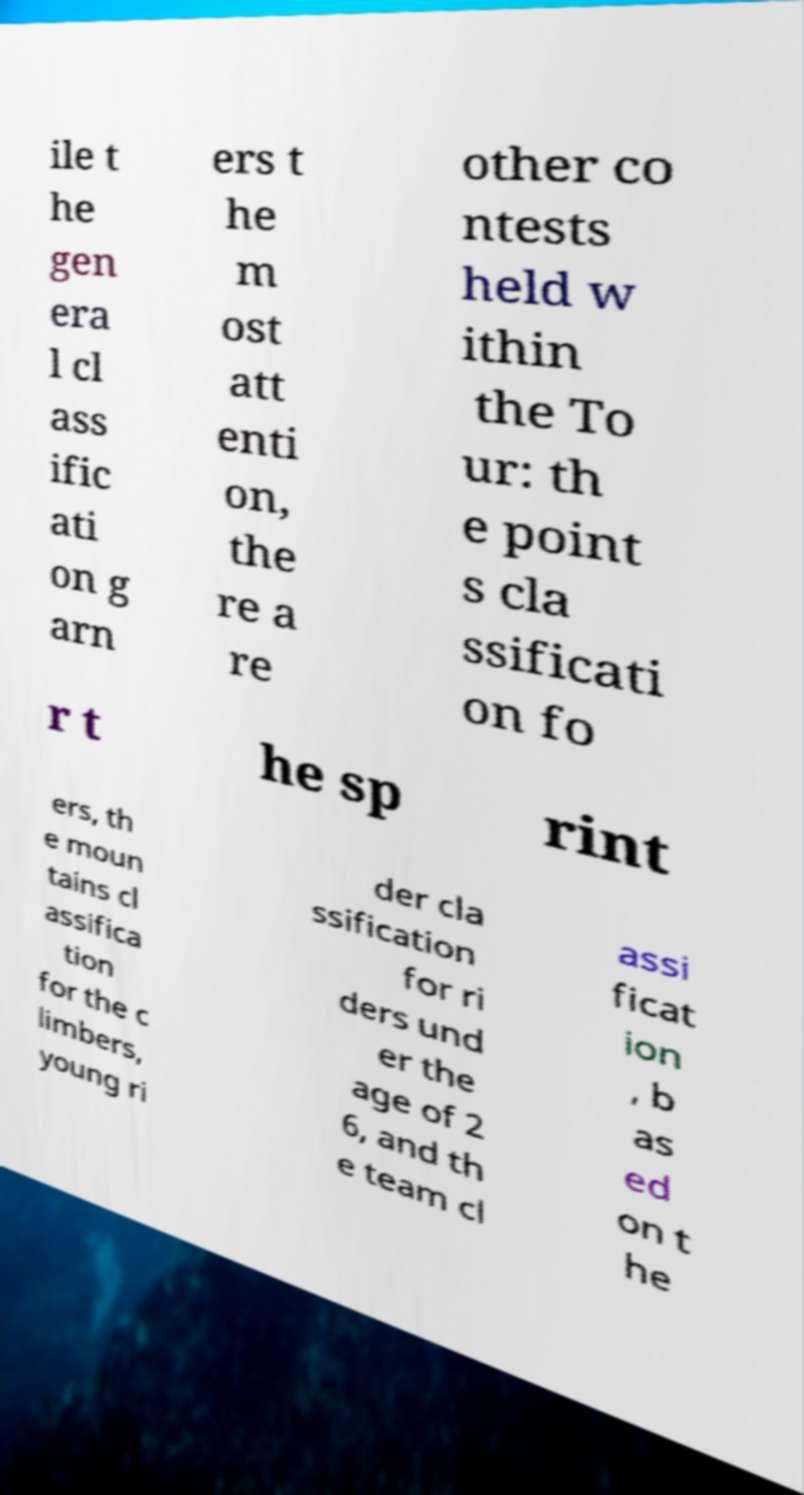Please identify and transcribe the text found in this image. ile t he gen era l cl ass ific ati on g arn ers t he m ost att enti on, the re a re other co ntests held w ithin the To ur: th e point s cla ssificati on fo r t he sp rint ers, th e moun tains cl assifica tion for the c limbers, young ri der cla ssification for ri ders und er the age of 2 6, and th e team cl assi ficat ion , b as ed on t he 